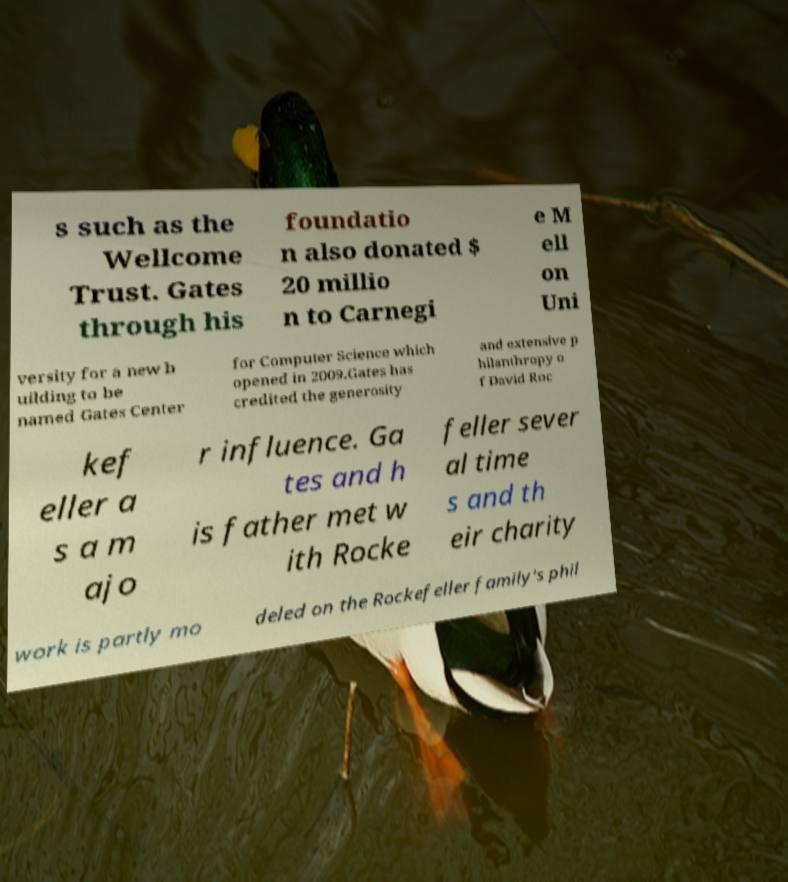I need the written content from this picture converted into text. Can you do that? s such as the Wellcome Trust. Gates through his foundatio n also donated $ 20 millio n to Carnegi e M ell on Uni versity for a new b uilding to be named Gates Center for Computer Science which opened in 2009.Gates has credited the generosity and extensive p hilanthropy o f David Roc kef eller a s a m ajo r influence. Ga tes and h is father met w ith Rocke feller sever al time s and th eir charity work is partly mo deled on the Rockefeller family's phil 